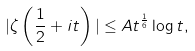Convert formula to latex. <formula><loc_0><loc_0><loc_500><loc_500>| \zeta \left ( \frac { 1 } { 2 } + i t \right ) | \leq A t ^ { \frac { 1 } { 6 } } \log t ,</formula> 